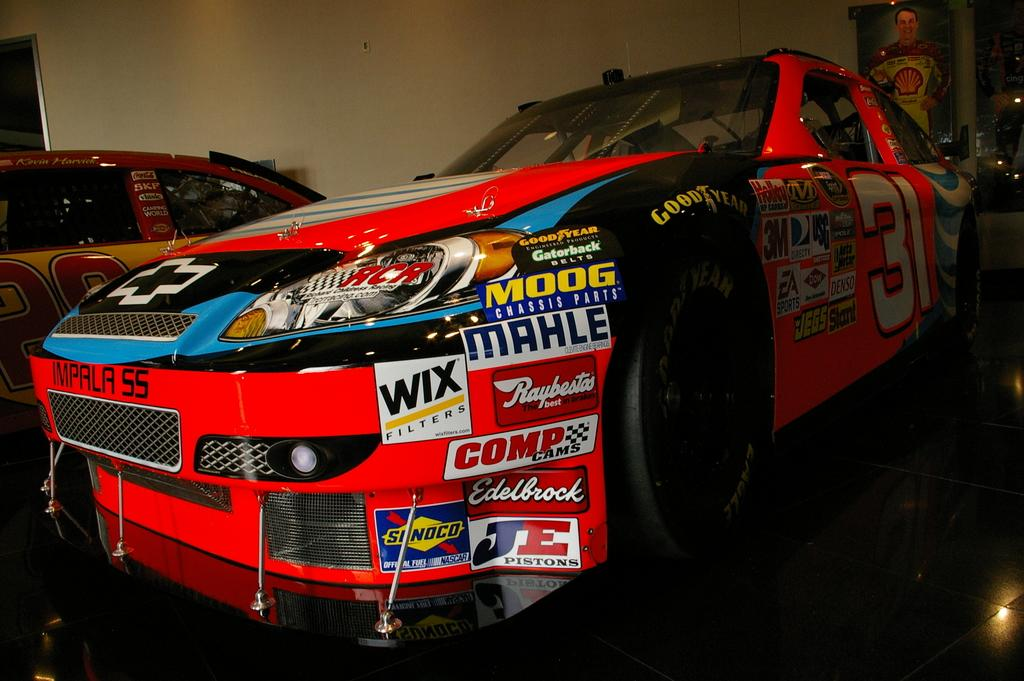What objects are on the floor in the image? There are cars on the floor in the image. What can be seen in the background of the image? There is a banner and a wall in the background of the image. How many pigs are visible in the image? There are no pigs present in the image. What type of kettle can be seen in the image? There is no kettle present in the image. 